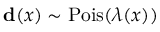Convert formula to latex. <formula><loc_0><loc_0><loc_500><loc_500>d ( x ) \sim P o i s ( \lambda ( x ) )</formula> 